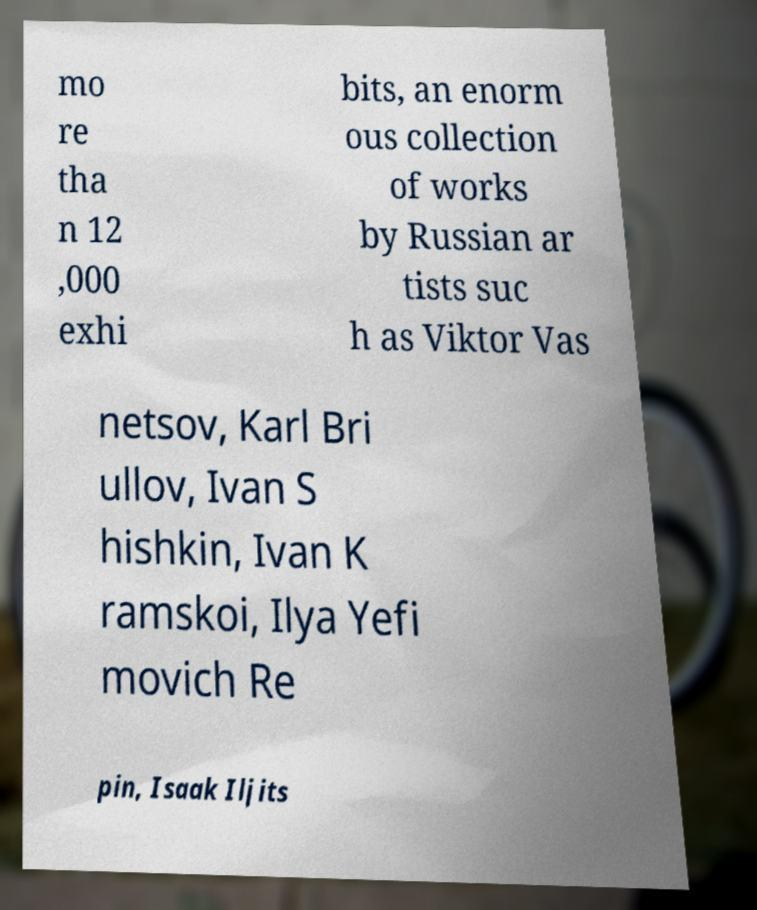What messages or text are displayed in this image? I need them in a readable, typed format. mo re tha n 12 ,000 exhi bits, an enorm ous collection of works by Russian ar tists suc h as Viktor Vas netsov, Karl Bri ullov, Ivan S hishkin, Ivan K ramskoi, Ilya Yefi movich Re pin, Isaak Iljits 